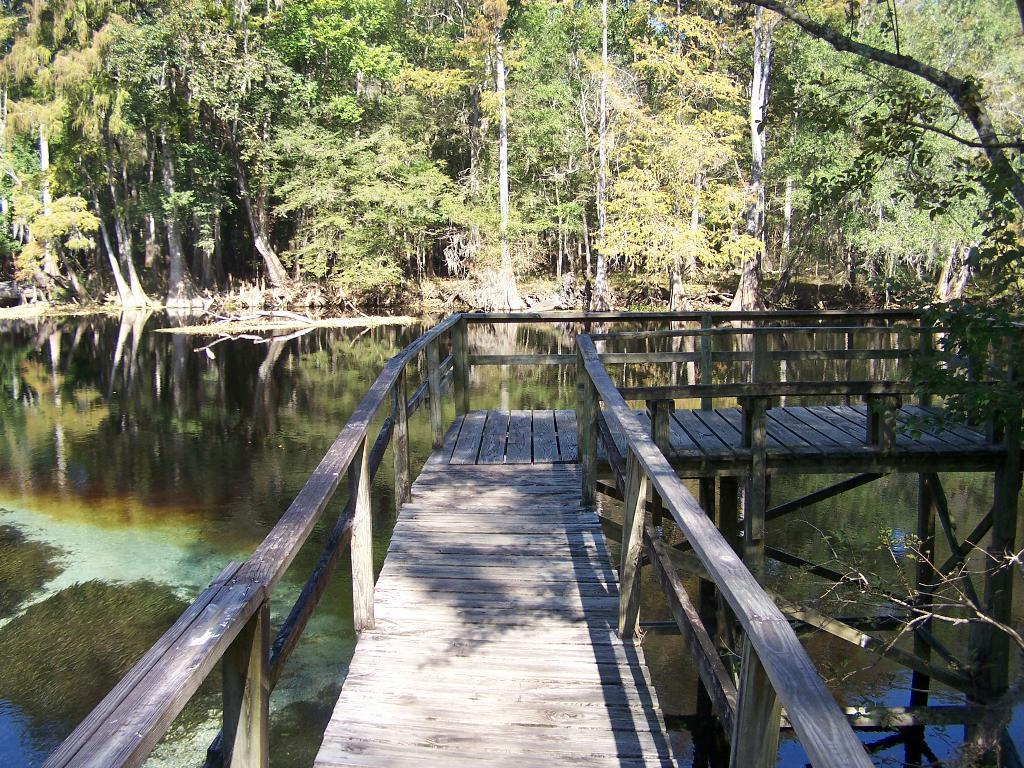What is the main structure in the center of the image? There is a bridge in the center of the image. What material is used for the bridge's railing? The bridge has a wooden railing. What can be seen in the background of the image? There are trees and water visible in the background of the image. What is present on the water's surface? Algae is present on the water. What else can be seen near the water? Sticks are visible in the water or on the shore. How does your uncle balance on the bridge in the image? There is no uncle present in the image, and therefore no one is balancing on the bridge. What type of oil can be seen floating on the water in the image? There is no oil present on the water in the image; it is covered with algae. 